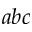<formula> <loc_0><loc_0><loc_500><loc_500>a b c</formula> 